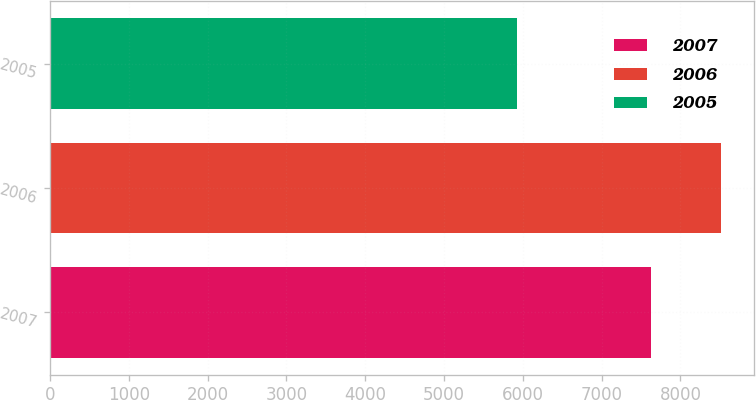Convert chart. <chart><loc_0><loc_0><loc_500><loc_500><bar_chart><fcel>2007<fcel>2006<fcel>2005<nl><fcel>7621<fcel>8514<fcel>5932<nl></chart> 